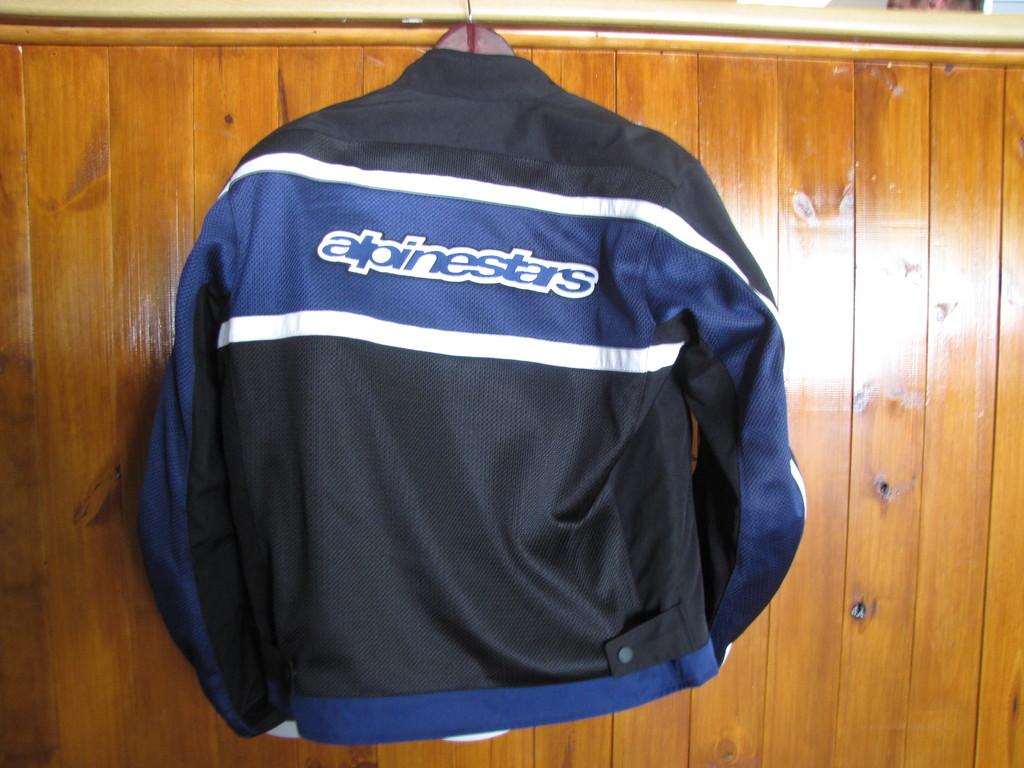What is the name on the jacket?
Ensure brevity in your answer.  Alpinestars. 